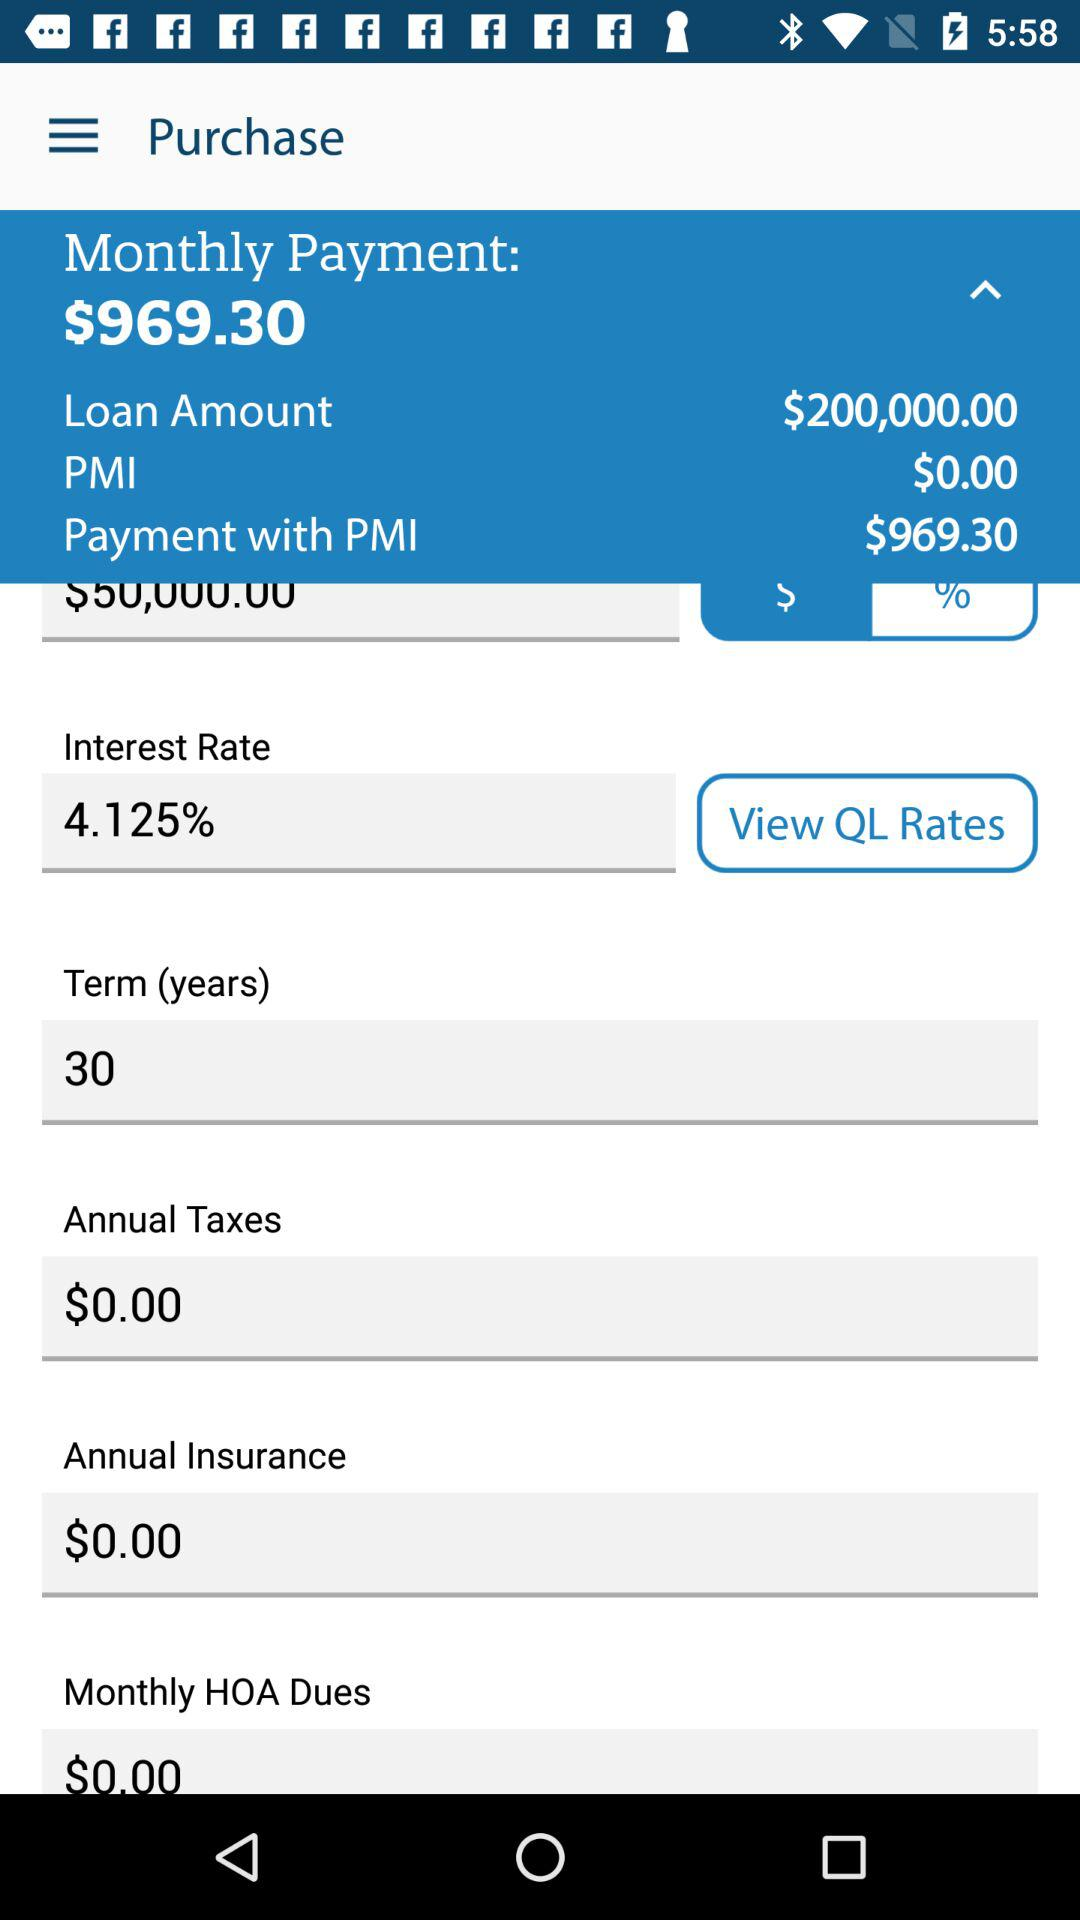Who is this application powered by?
When the provided information is insufficient, respond with <no answer>. <no answer> 